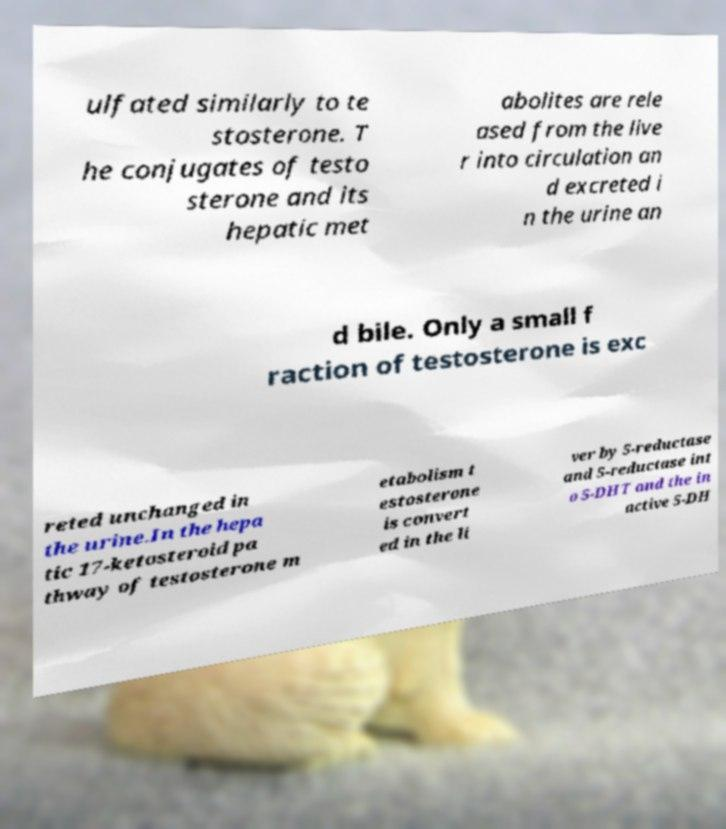Can you accurately transcribe the text from the provided image for me? ulfated similarly to te stosterone. T he conjugates of testo sterone and its hepatic met abolites are rele ased from the live r into circulation an d excreted i n the urine an d bile. Only a small f raction of testosterone is exc reted unchanged in the urine.In the hepa tic 17-ketosteroid pa thway of testosterone m etabolism t estosterone is convert ed in the li ver by 5-reductase and 5-reductase int o 5-DHT and the in active 5-DH 